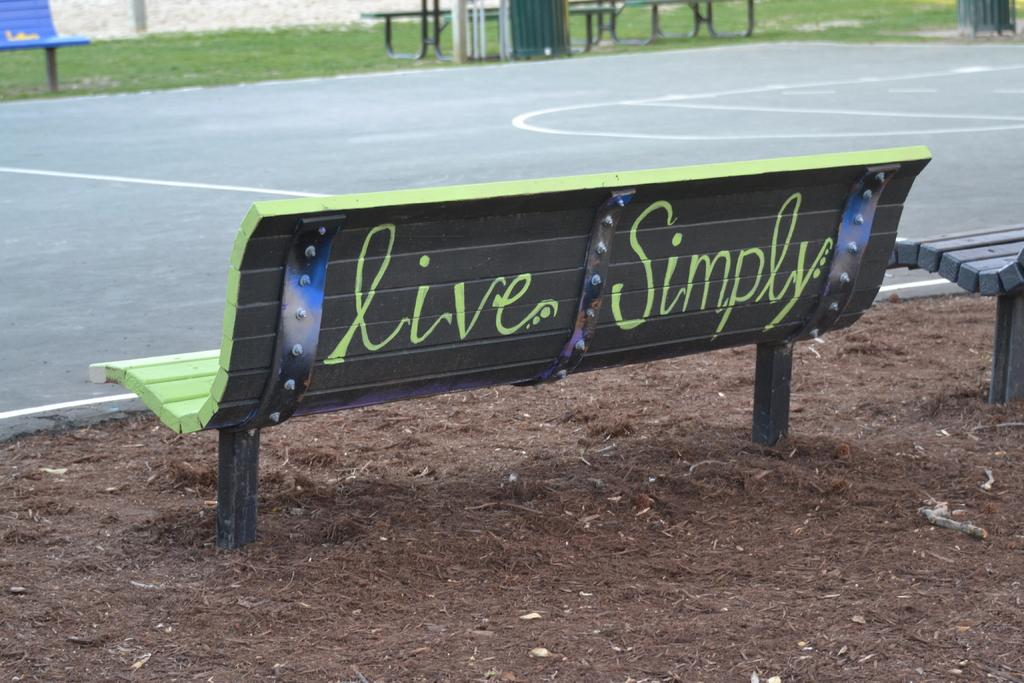What type of surface can be seen in the image? There is a road in the image. What type of seating is available in the image? There are benches in the image. What type of vegetation is present in the image? There is grass in the image. What type of structure is visible in the image? There is a wall in the image. What part of the ground is visible in the image? The ground is visible in the image. How many brass instruments can be seen in the image? There are no brass instruments present in the image. 